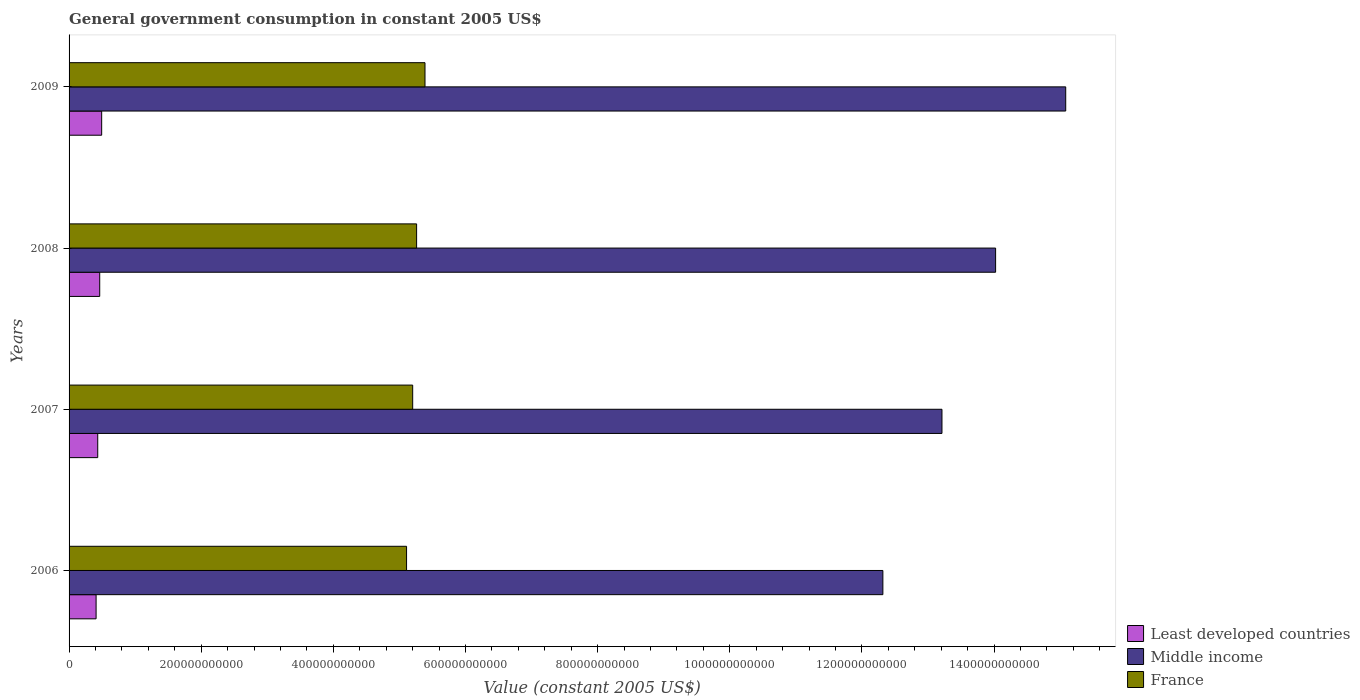How many groups of bars are there?
Make the answer very short. 4. What is the label of the 2nd group of bars from the top?
Offer a terse response. 2008. In how many cases, is the number of bars for a given year not equal to the number of legend labels?
Your response must be concise. 0. What is the government conusmption in Least developed countries in 2006?
Provide a succinct answer. 4.09e+1. Across all years, what is the maximum government conusmption in France?
Your answer should be very brief. 5.39e+11. Across all years, what is the minimum government conusmption in Least developed countries?
Make the answer very short. 4.09e+1. In which year was the government conusmption in Least developed countries minimum?
Ensure brevity in your answer.  2006. What is the total government conusmption in Middle income in the graph?
Offer a very short reply. 5.46e+12. What is the difference between the government conusmption in France in 2006 and that in 2008?
Provide a short and direct response. -1.52e+1. What is the difference between the government conusmption in Least developed countries in 2006 and the government conusmption in France in 2007?
Offer a very short reply. -4.79e+11. What is the average government conusmption in France per year?
Provide a succinct answer. 5.24e+11. In the year 2009, what is the difference between the government conusmption in France and government conusmption in Middle income?
Your response must be concise. -9.70e+11. What is the ratio of the government conusmption in Least developed countries in 2006 to that in 2009?
Keep it short and to the point. 0.83. What is the difference between the highest and the second highest government conusmption in Middle income?
Provide a short and direct response. 1.06e+11. What is the difference between the highest and the lowest government conusmption in Least developed countries?
Provide a short and direct response. 8.43e+09. Is the sum of the government conusmption in Least developed countries in 2007 and 2008 greater than the maximum government conusmption in France across all years?
Keep it short and to the point. No. What does the 1st bar from the top in 2009 represents?
Keep it short and to the point. France. Are all the bars in the graph horizontal?
Your response must be concise. Yes. How many years are there in the graph?
Offer a terse response. 4. What is the difference between two consecutive major ticks on the X-axis?
Give a very brief answer. 2.00e+11. Are the values on the major ticks of X-axis written in scientific E-notation?
Your answer should be very brief. No. Does the graph contain any zero values?
Ensure brevity in your answer.  No. Does the graph contain grids?
Your answer should be compact. No. How are the legend labels stacked?
Make the answer very short. Vertical. What is the title of the graph?
Give a very brief answer. General government consumption in constant 2005 US$. What is the label or title of the X-axis?
Give a very brief answer. Value (constant 2005 US$). What is the label or title of the Y-axis?
Your answer should be very brief. Years. What is the Value (constant 2005 US$) in Least developed countries in 2006?
Provide a short and direct response. 4.09e+1. What is the Value (constant 2005 US$) in Middle income in 2006?
Give a very brief answer. 1.23e+12. What is the Value (constant 2005 US$) of France in 2006?
Ensure brevity in your answer.  5.11e+11. What is the Value (constant 2005 US$) in Least developed countries in 2007?
Provide a short and direct response. 4.34e+1. What is the Value (constant 2005 US$) of Middle income in 2007?
Your answer should be compact. 1.32e+12. What is the Value (constant 2005 US$) of France in 2007?
Provide a short and direct response. 5.20e+11. What is the Value (constant 2005 US$) in Least developed countries in 2008?
Provide a short and direct response. 4.64e+1. What is the Value (constant 2005 US$) in Middle income in 2008?
Your response must be concise. 1.40e+12. What is the Value (constant 2005 US$) of France in 2008?
Offer a very short reply. 5.26e+11. What is the Value (constant 2005 US$) in Least developed countries in 2009?
Your response must be concise. 4.93e+1. What is the Value (constant 2005 US$) in Middle income in 2009?
Provide a short and direct response. 1.51e+12. What is the Value (constant 2005 US$) of France in 2009?
Give a very brief answer. 5.39e+11. Across all years, what is the maximum Value (constant 2005 US$) of Least developed countries?
Your answer should be compact. 4.93e+1. Across all years, what is the maximum Value (constant 2005 US$) of Middle income?
Ensure brevity in your answer.  1.51e+12. Across all years, what is the maximum Value (constant 2005 US$) in France?
Offer a terse response. 5.39e+11. Across all years, what is the minimum Value (constant 2005 US$) in Least developed countries?
Keep it short and to the point. 4.09e+1. Across all years, what is the minimum Value (constant 2005 US$) in Middle income?
Provide a short and direct response. 1.23e+12. Across all years, what is the minimum Value (constant 2005 US$) of France?
Ensure brevity in your answer.  5.11e+11. What is the total Value (constant 2005 US$) of Least developed countries in the graph?
Your response must be concise. 1.80e+11. What is the total Value (constant 2005 US$) in Middle income in the graph?
Ensure brevity in your answer.  5.46e+12. What is the total Value (constant 2005 US$) of France in the graph?
Offer a very short reply. 2.10e+12. What is the difference between the Value (constant 2005 US$) in Least developed countries in 2006 and that in 2007?
Give a very brief answer. -2.49e+09. What is the difference between the Value (constant 2005 US$) in Middle income in 2006 and that in 2007?
Your response must be concise. -8.94e+1. What is the difference between the Value (constant 2005 US$) of France in 2006 and that in 2007?
Your response must be concise. -9.25e+09. What is the difference between the Value (constant 2005 US$) in Least developed countries in 2006 and that in 2008?
Offer a very short reply. -5.49e+09. What is the difference between the Value (constant 2005 US$) of Middle income in 2006 and that in 2008?
Make the answer very short. -1.71e+11. What is the difference between the Value (constant 2005 US$) in France in 2006 and that in 2008?
Make the answer very short. -1.52e+1. What is the difference between the Value (constant 2005 US$) of Least developed countries in 2006 and that in 2009?
Offer a terse response. -8.43e+09. What is the difference between the Value (constant 2005 US$) of Middle income in 2006 and that in 2009?
Give a very brief answer. -2.77e+11. What is the difference between the Value (constant 2005 US$) in France in 2006 and that in 2009?
Your answer should be very brief. -2.79e+1. What is the difference between the Value (constant 2005 US$) in Least developed countries in 2007 and that in 2008?
Your answer should be very brief. -3.00e+09. What is the difference between the Value (constant 2005 US$) of Middle income in 2007 and that in 2008?
Provide a short and direct response. -8.12e+1. What is the difference between the Value (constant 2005 US$) of France in 2007 and that in 2008?
Make the answer very short. -5.95e+09. What is the difference between the Value (constant 2005 US$) of Least developed countries in 2007 and that in 2009?
Ensure brevity in your answer.  -5.94e+09. What is the difference between the Value (constant 2005 US$) of Middle income in 2007 and that in 2009?
Offer a terse response. -1.87e+11. What is the difference between the Value (constant 2005 US$) of France in 2007 and that in 2009?
Offer a terse response. -1.86e+1. What is the difference between the Value (constant 2005 US$) of Least developed countries in 2008 and that in 2009?
Provide a succinct answer. -2.94e+09. What is the difference between the Value (constant 2005 US$) of Middle income in 2008 and that in 2009?
Offer a very short reply. -1.06e+11. What is the difference between the Value (constant 2005 US$) in France in 2008 and that in 2009?
Provide a short and direct response. -1.27e+1. What is the difference between the Value (constant 2005 US$) in Least developed countries in 2006 and the Value (constant 2005 US$) in Middle income in 2007?
Make the answer very short. -1.28e+12. What is the difference between the Value (constant 2005 US$) of Least developed countries in 2006 and the Value (constant 2005 US$) of France in 2007?
Offer a terse response. -4.79e+11. What is the difference between the Value (constant 2005 US$) in Middle income in 2006 and the Value (constant 2005 US$) in France in 2007?
Give a very brief answer. 7.12e+11. What is the difference between the Value (constant 2005 US$) in Least developed countries in 2006 and the Value (constant 2005 US$) in Middle income in 2008?
Provide a succinct answer. -1.36e+12. What is the difference between the Value (constant 2005 US$) of Least developed countries in 2006 and the Value (constant 2005 US$) of France in 2008?
Make the answer very short. -4.85e+11. What is the difference between the Value (constant 2005 US$) of Middle income in 2006 and the Value (constant 2005 US$) of France in 2008?
Provide a short and direct response. 7.06e+11. What is the difference between the Value (constant 2005 US$) of Least developed countries in 2006 and the Value (constant 2005 US$) of Middle income in 2009?
Offer a terse response. -1.47e+12. What is the difference between the Value (constant 2005 US$) in Least developed countries in 2006 and the Value (constant 2005 US$) in France in 2009?
Your response must be concise. -4.98e+11. What is the difference between the Value (constant 2005 US$) of Middle income in 2006 and the Value (constant 2005 US$) of France in 2009?
Provide a short and direct response. 6.93e+11. What is the difference between the Value (constant 2005 US$) in Least developed countries in 2007 and the Value (constant 2005 US$) in Middle income in 2008?
Keep it short and to the point. -1.36e+12. What is the difference between the Value (constant 2005 US$) in Least developed countries in 2007 and the Value (constant 2005 US$) in France in 2008?
Ensure brevity in your answer.  -4.83e+11. What is the difference between the Value (constant 2005 US$) in Middle income in 2007 and the Value (constant 2005 US$) in France in 2008?
Make the answer very short. 7.95e+11. What is the difference between the Value (constant 2005 US$) of Least developed countries in 2007 and the Value (constant 2005 US$) of Middle income in 2009?
Provide a short and direct response. -1.47e+12. What is the difference between the Value (constant 2005 US$) in Least developed countries in 2007 and the Value (constant 2005 US$) in France in 2009?
Your answer should be compact. -4.95e+11. What is the difference between the Value (constant 2005 US$) of Middle income in 2007 and the Value (constant 2005 US$) of France in 2009?
Ensure brevity in your answer.  7.82e+11. What is the difference between the Value (constant 2005 US$) of Least developed countries in 2008 and the Value (constant 2005 US$) of Middle income in 2009?
Ensure brevity in your answer.  -1.46e+12. What is the difference between the Value (constant 2005 US$) of Least developed countries in 2008 and the Value (constant 2005 US$) of France in 2009?
Offer a terse response. -4.92e+11. What is the difference between the Value (constant 2005 US$) of Middle income in 2008 and the Value (constant 2005 US$) of France in 2009?
Your answer should be very brief. 8.64e+11. What is the average Value (constant 2005 US$) of Least developed countries per year?
Keep it short and to the point. 4.50e+1. What is the average Value (constant 2005 US$) of Middle income per year?
Offer a terse response. 1.37e+12. What is the average Value (constant 2005 US$) in France per year?
Your answer should be compact. 5.24e+11. In the year 2006, what is the difference between the Value (constant 2005 US$) in Least developed countries and Value (constant 2005 US$) in Middle income?
Ensure brevity in your answer.  -1.19e+12. In the year 2006, what is the difference between the Value (constant 2005 US$) of Least developed countries and Value (constant 2005 US$) of France?
Keep it short and to the point. -4.70e+11. In the year 2006, what is the difference between the Value (constant 2005 US$) in Middle income and Value (constant 2005 US$) in France?
Give a very brief answer. 7.21e+11. In the year 2007, what is the difference between the Value (constant 2005 US$) of Least developed countries and Value (constant 2005 US$) of Middle income?
Give a very brief answer. -1.28e+12. In the year 2007, what is the difference between the Value (constant 2005 US$) in Least developed countries and Value (constant 2005 US$) in France?
Provide a short and direct response. -4.77e+11. In the year 2007, what is the difference between the Value (constant 2005 US$) of Middle income and Value (constant 2005 US$) of France?
Provide a short and direct response. 8.01e+11. In the year 2008, what is the difference between the Value (constant 2005 US$) of Least developed countries and Value (constant 2005 US$) of Middle income?
Your answer should be compact. -1.36e+12. In the year 2008, what is the difference between the Value (constant 2005 US$) of Least developed countries and Value (constant 2005 US$) of France?
Provide a succinct answer. -4.80e+11. In the year 2008, what is the difference between the Value (constant 2005 US$) of Middle income and Value (constant 2005 US$) of France?
Your response must be concise. 8.76e+11. In the year 2009, what is the difference between the Value (constant 2005 US$) in Least developed countries and Value (constant 2005 US$) in Middle income?
Offer a very short reply. -1.46e+12. In the year 2009, what is the difference between the Value (constant 2005 US$) in Least developed countries and Value (constant 2005 US$) in France?
Provide a succinct answer. -4.89e+11. In the year 2009, what is the difference between the Value (constant 2005 US$) of Middle income and Value (constant 2005 US$) of France?
Ensure brevity in your answer.  9.70e+11. What is the ratio of the Value (constant 2005 US$) of Least developed countries in 2006 to that in 2007?
Your answer should be compact. 0.94. What is the ratio of the Value (constant 2005 US$) in Middle income in 2006 to that in 2007?
Ensure brevity in your answer.  0.93. What is the ratio of the Value (constant 2005 US$) in France in 2006 to that in 2007?
Ensure brevity in your answer.  0.98. What is the ratio of the Value (constant 2005 US$) in Least developed countries in 2006 to that in 2008?
Offer a very short reply. 0.88. What is the ratio of the Value (constant 2005 US$) in Middle income in 2006 to that in 2008?
Provide a succinct answer. 0.88. What is the ratio of the Value (constant 2005 US$) of France in 2006 to that in 2008?
Your answer should be compact. 0.97. What is the ratio of the Value (constant 2005 US$) in Least developed countries in 2006 to that in 2009?
Offer a very short reply. 0.83. What is the ratio of the Value (constant 2005 US$) in Middle income in 2006 to that in 2009?
Your answer should be very brief. 0.82. What is the ratio of the Value (constant 2005 US$) in France in 2006 to that in 2009?
Offer a terse response. 0.95. What is the ratio of the Value (constant 2005 US$) in Least developed countries in 2007 to that in 2008?
Provide a succinct answer. 0.94. What is the ratio of the Value (constant 2005 US$) in Middle income in 2007 to that in 2008?
Give a very brief answer. 0.94. What is the ratio of the Value (constant 2005 US$) in France in 2007 to that in 2008?
Make the answer very short. 0.99. What is the ratio of the Value (constant 2005 US$) of Least developed countries in 2007 to that in 2009?
Make the answer very short. 0.88. What is the ratio of the Value (constant 2005 US$) in Middle income in 2007 to that in 2009?
Provide a short and direct response. 0.88. What is the ratio of the Value (constant 2005 US$) of France in 2007 to that in 2009?
Your answer should be very brief. 0.97. What is the ratio of the Value (constant 2005 US$) of Least developed countries in 2008 to that in 2009?
Offer a very short reply. 0.94. What is the ratio of the Value (constant 2005 US$) of Middle income in 2008 to that in 2009?
Provide a succinct answer. 0.93. What is the ratio of the Value (constant 2005 US$) in France in 2008 to that in 2009?
Offer a very short reply. 0.98. What is the difference between the highest and the second highest Value (constant 2005 US$) in Least developed countries?
Give a very brief answer. 2.94e+09. What is the difference between the highest and the second highest Value (constant 2005 US$) in Middle income?
Give a very brief answer. 1.06e+11. What is the difference between the highest and the second highest Value (constant 2005 US$) in France?
Ensure brevity in your answer.  1.27e+1. What is the difference between the highest and the lowest Value (constant 2005 US$) of Least developed countries?
Your answer should be very brief. 8.43e+09. What is the difference between the highest and the lowest Value (constant 2005 US$) in Middle income?
Provide a short and direct response. 2.77e+11. What is the difference between the highest and the lowest Value (constant 2005 US$) in France?
Your answer should be compact. 2.79e+1. 